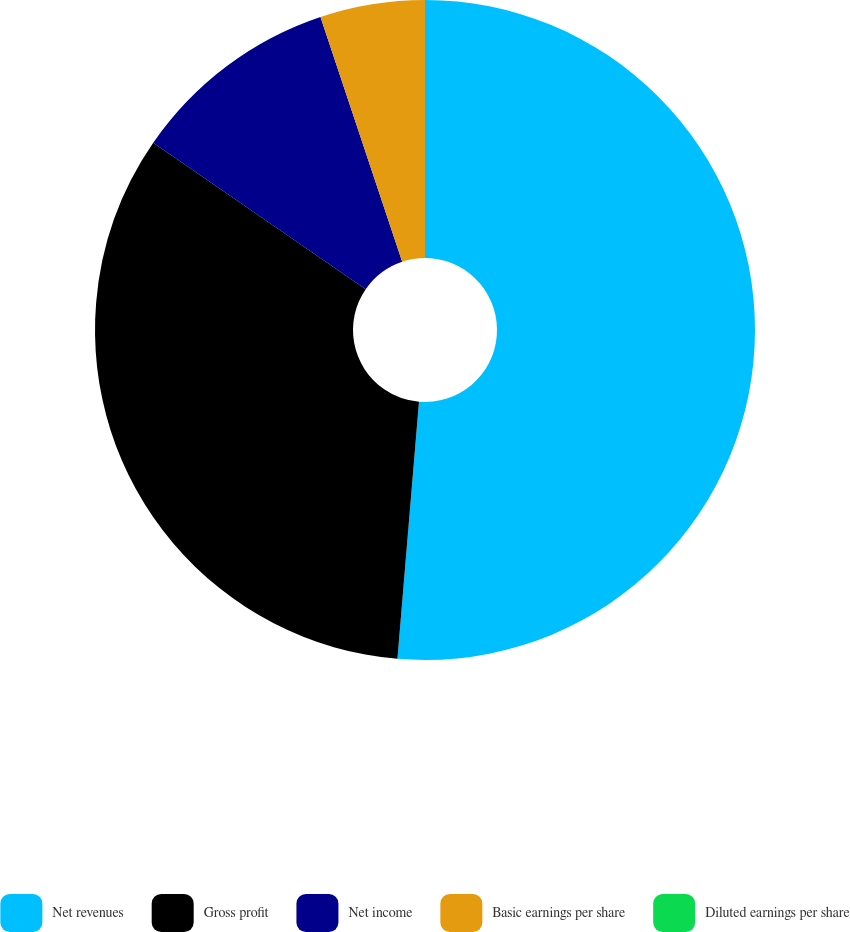Convert chart. <chart><loc_0><loc_0><loc_500><loc_500><pie_chart><fcel>Net revenues<fcel>Gross profit<fcel>Net income<fcel>Basic earnings per share<fcel>Diluted earnings per share<nl><fcel>51.33%<fcel>33.27%<fcel>10.27%<fcel>5.13%<fcel>0.0%<nl></chart> 